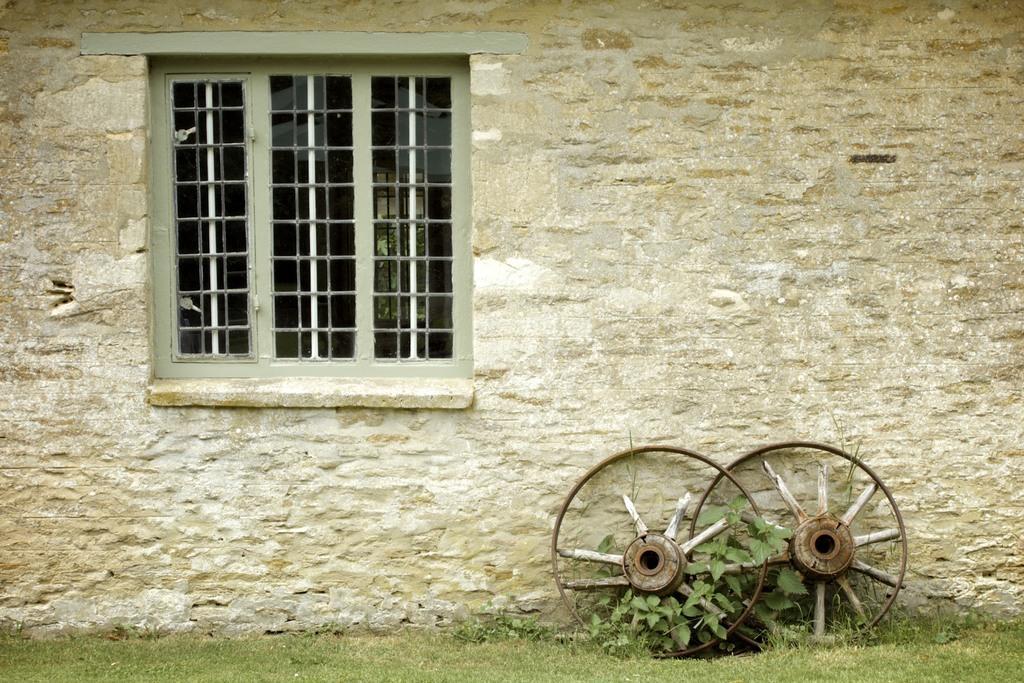Describe this image in one or two sentences. In this image we can see the building wall and also the window. We can also see the wheels, plant and also the grass. 